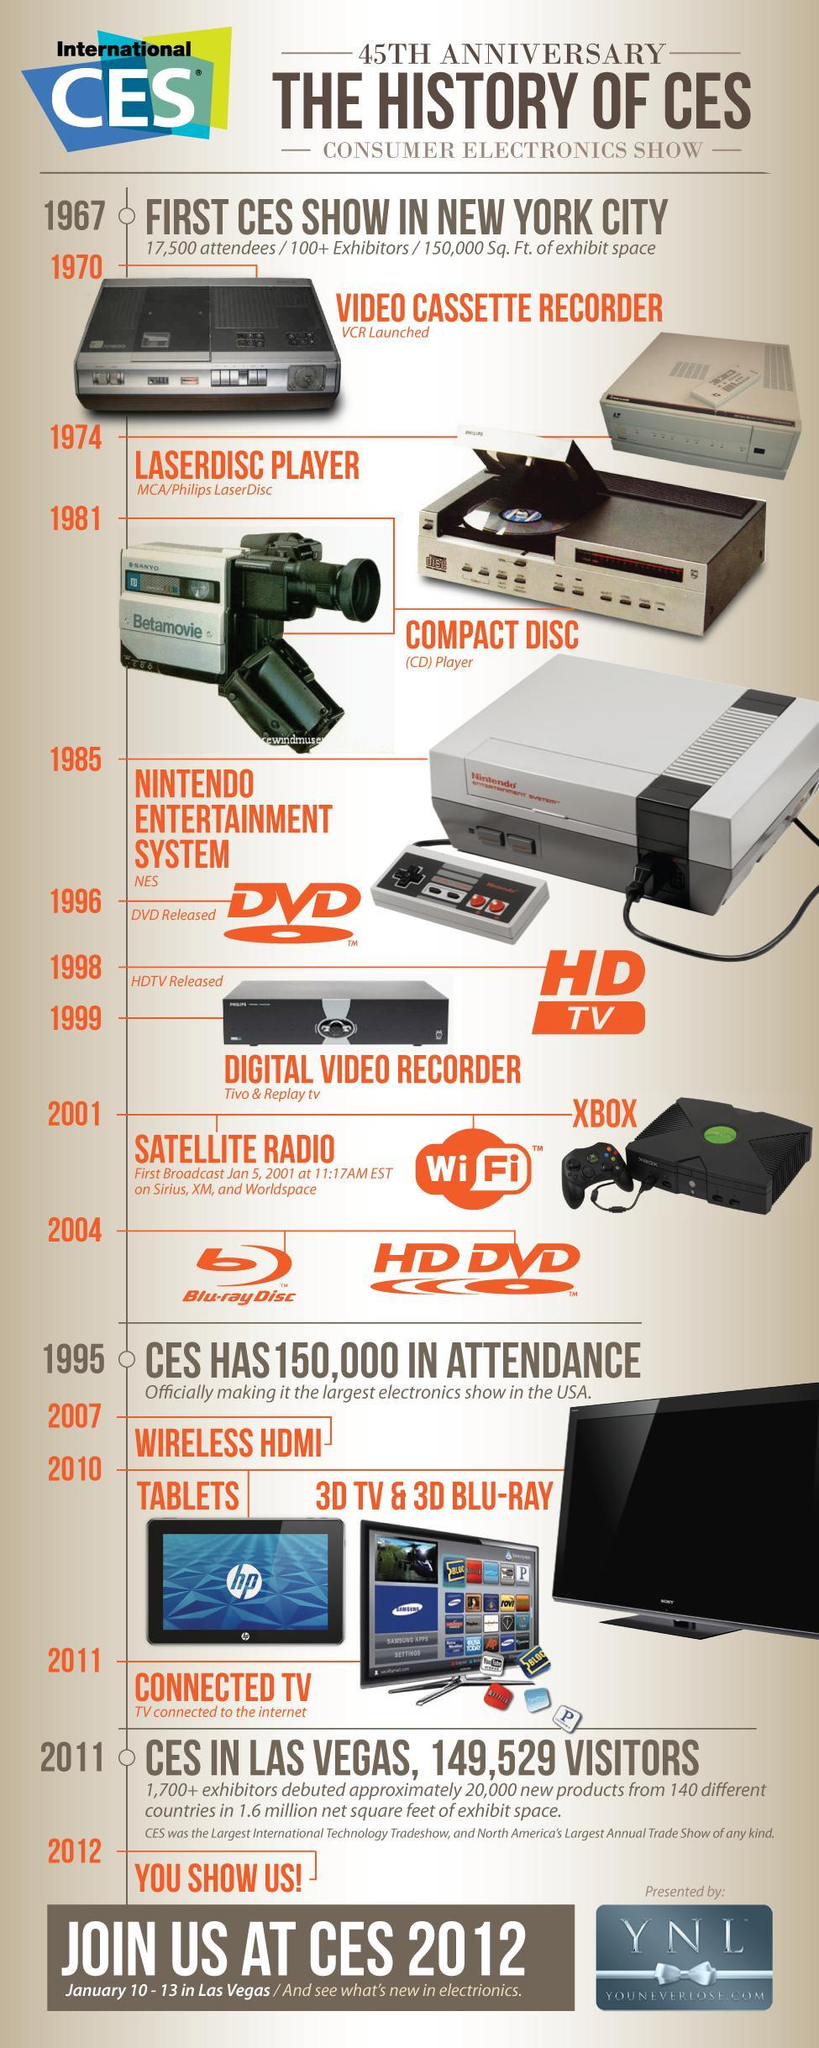What is the number of DVD images in this infographic?
Answer the question with a short phrase. 1 What is the number of television images in this infographic? 2 What is the number of tablets in this infographic? 1 